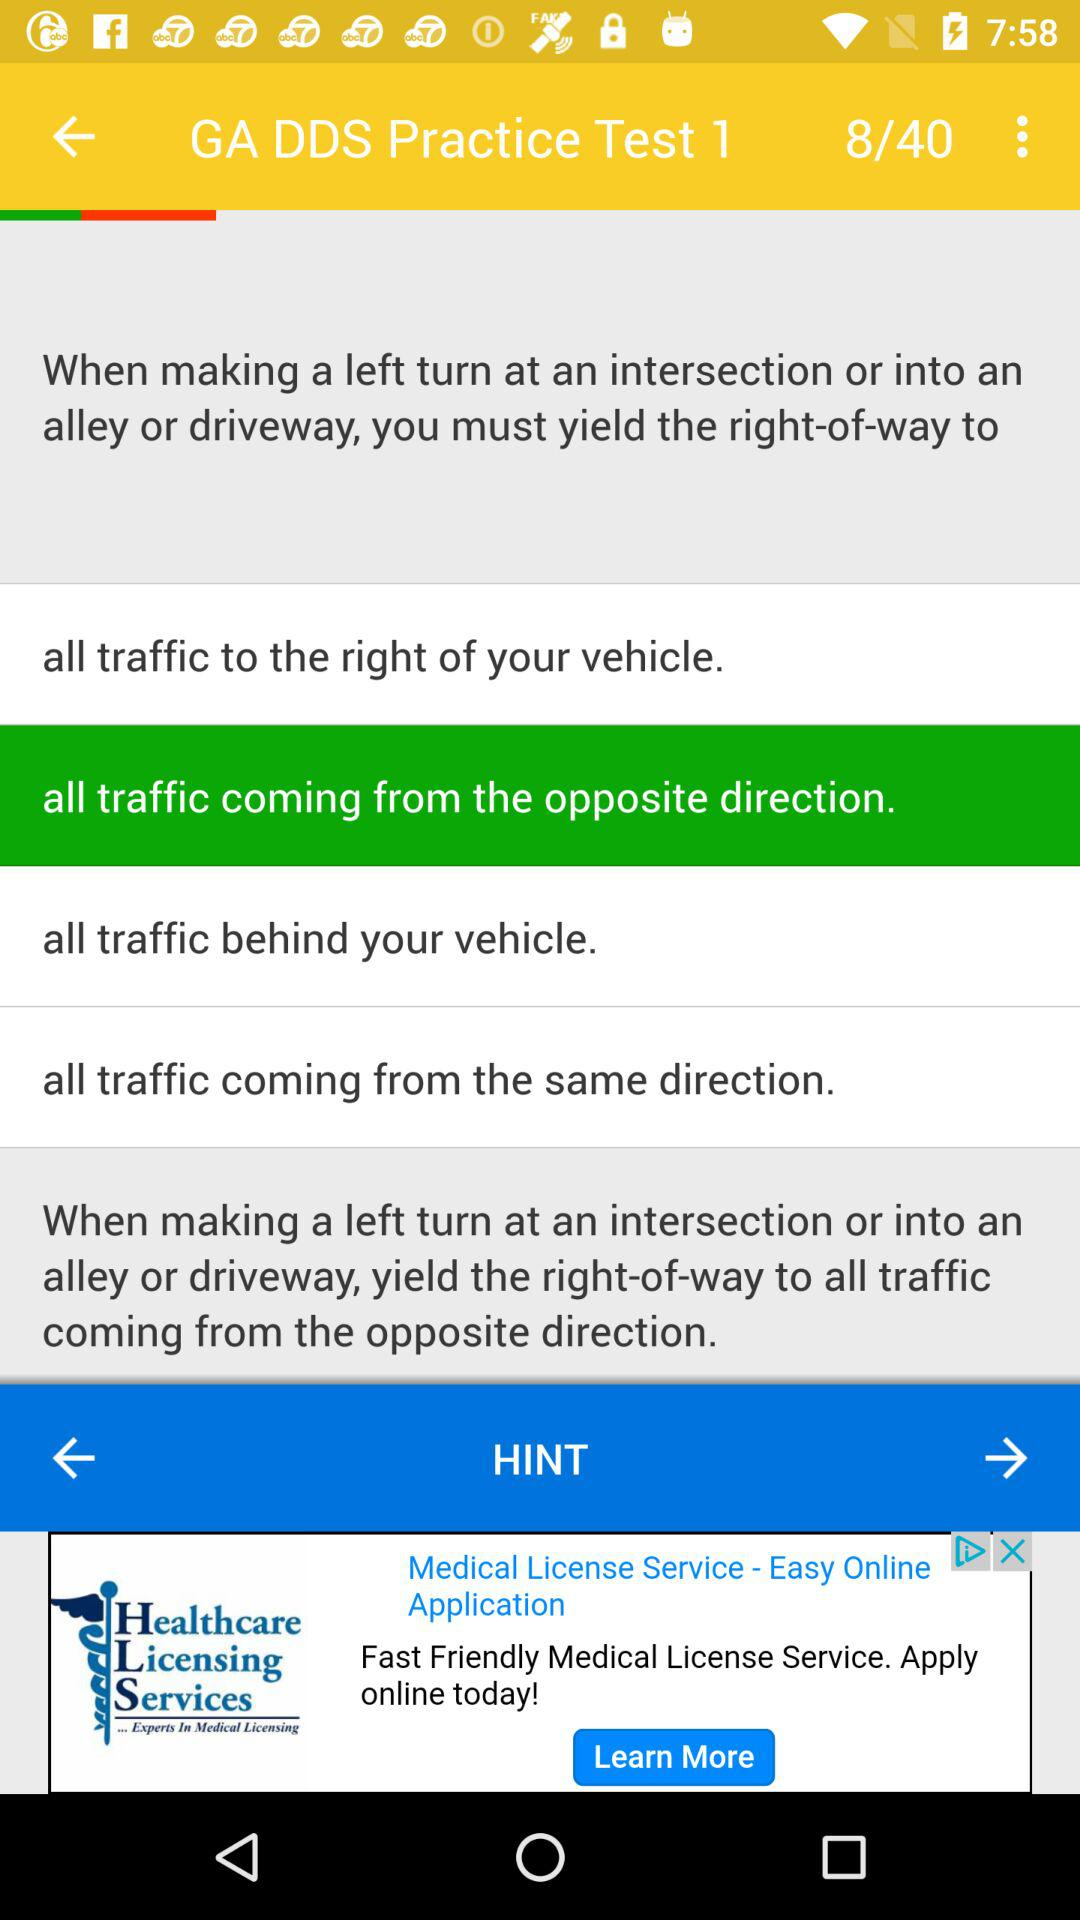What is the name of the application?
When the provided information is insufficient, respond with <no answer>. <no answer> 